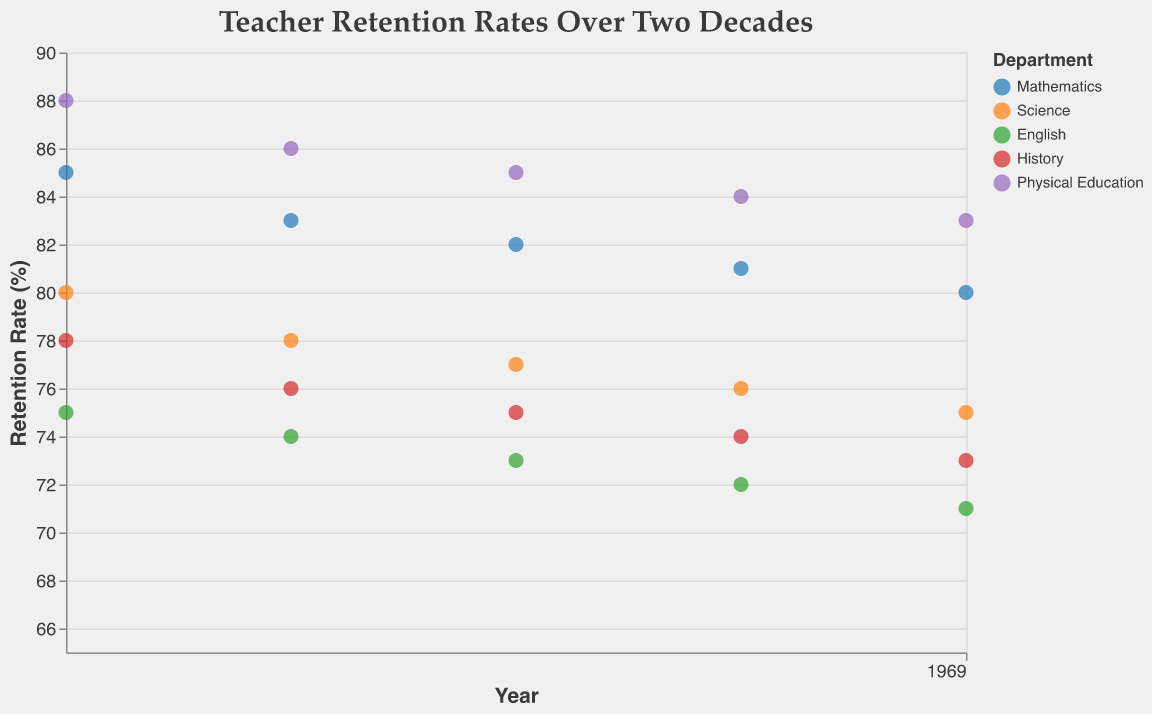What is the title of the figure? The title is displayed at the top of the figure and reads "Teacher Retention Rates Over Two Decades".
Answer: Teacher Retention Rates Over Two Decades What departments are included in the figure? The legend shows the departments included: Mathematics, Science, English, History, Physical Education.
Answer: Mathematics, Science, English, History, Physical Education Which department has the highest retention rate in 2003? For the year 2003, looking at the y-axis values, Physical Education has the highest retention rate of 88%.
Answer: Physical Education How does the retention rate for Science change from 2003 to 2023? For Science, the retention rate decreases progressively from 80% in 2003 to 75% in 2023.
Answer: It decreases What is the trend in the retention rate for Mathematics over the two decades? The trend line for Mathematics shows a gradual decline in retention rate from 85% in 2003 to 80% in 2023.
Answer: Declining Compare the retention rates of English and History in 2018. Which is higher, and by how much? In 2018, History has a retention rate of 74%, while English has 72%. Hence, History's retention rate is higher by 2%.
Answer: History, by 2% What are the average retention rates for all departments in 2008? To calculate the average: (83 + 78 + 74 + 76 + 86) / 5 = 79.4%.
Answer: 79.4% Does any department show a constant retention rate over the years? By observing the lines, no department maintains a perfectly constant retention rate; all show some variation over the years.
Answer: No From the trend lines, which department shows the least decrease in retention rates over the two decades? The trend line for Physical Education shows the smallest decrease compared to other departments, indicating the least reduction in retention rates.
Answer: Physical Education How do the changes in retention rates for Mathematics and English compare between 2003 and 2023? Mathematics decreases from 85% to 80%, a change of -5%. English decreases from 75% to 71%, a change of -4%. Mathematics' retention rate drops slightly more than English's.
Answer: Mathematics decreases more (-5% vs. -4%) 